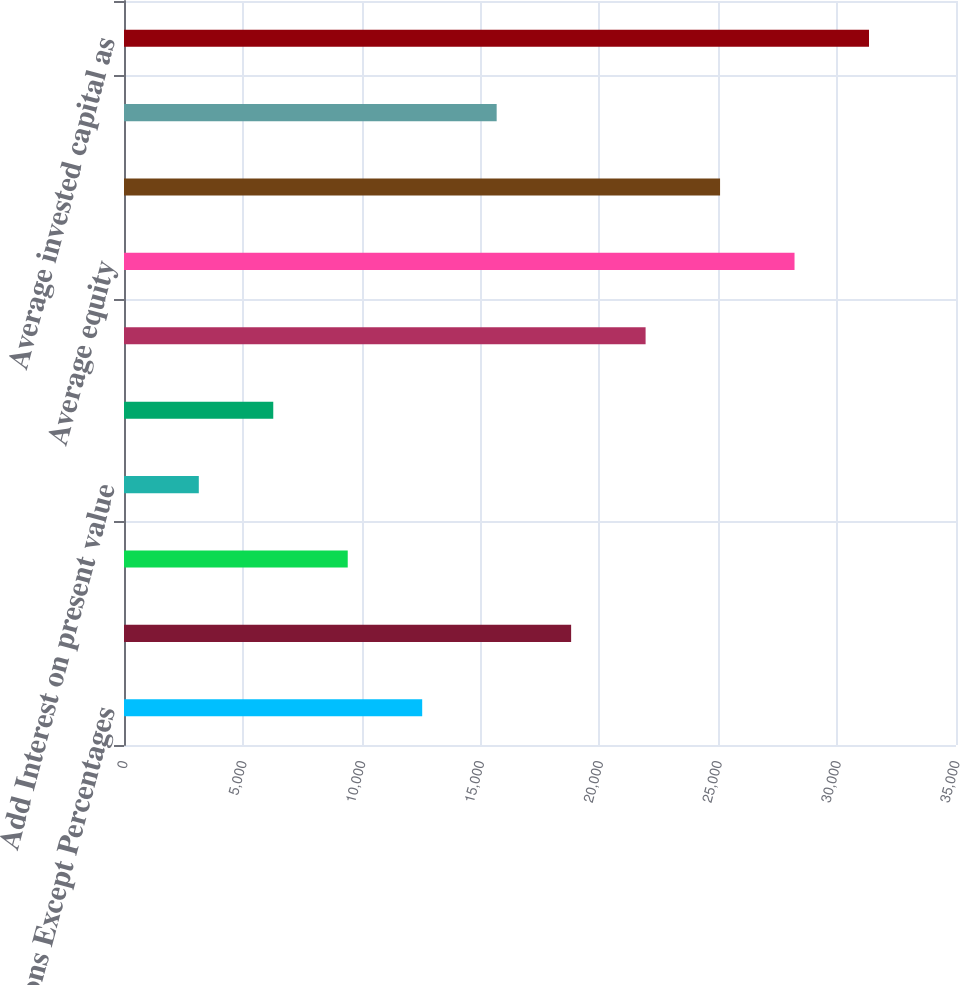Convert chart. <chart><loc_0><loc_0><loc_500><loc_500><bar_chart><fcel>Millions Except Percentages<fcel>Net income<fcel>Add Interest expense<fcel>Add Interest on present value<fcel>Less Taxes on interest<fcel>Net operating profit after<fcel>Average equity<fcel>Add Average debt<fcel>Add Average present value of<fcel>Average invested capital as<nl><fcel>12544.4<fcel>18809.6<fcel>9411.8<fcel>3146.6<fcel>6279.2<fcel>21942.2<fcel>28207.4<fcel>25074.8<fcel>15677<fcel>31340<nl></chart> 